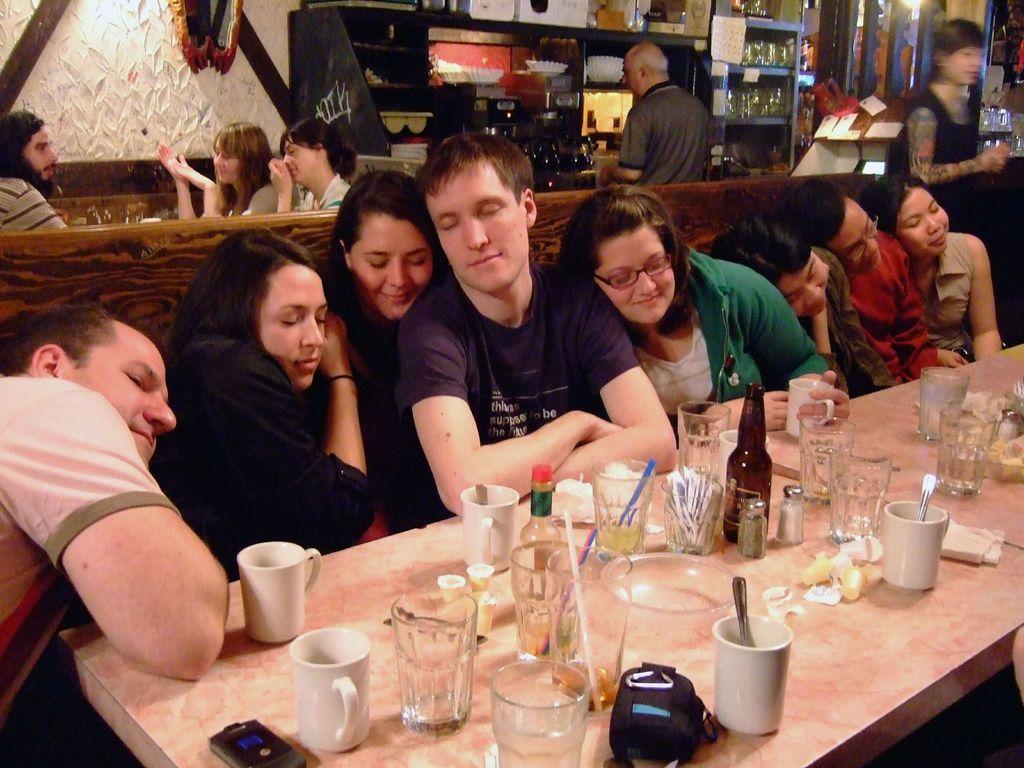Describe this image in one or two sentences. It is a table there are glasses,cups on this. These people are acting like they are sleeping. He is the middle person he wear a T-Shirt. They are sitting on the sofa behind them there are two women sitting. There is a wall here. 